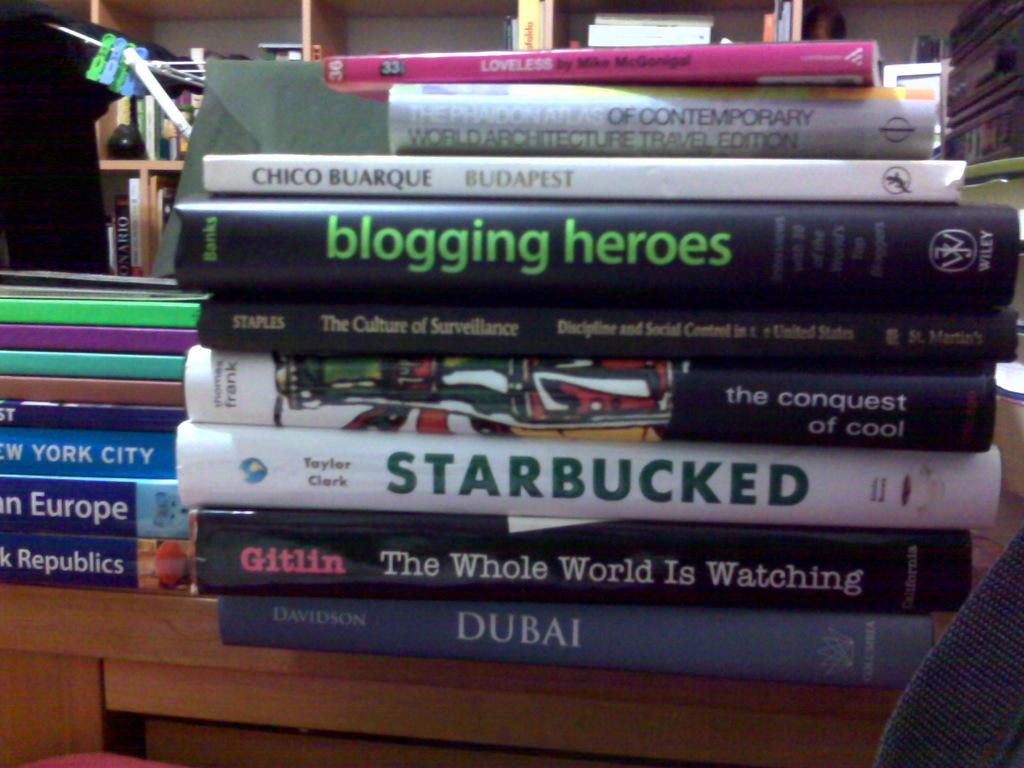Provide a one-sentence caption for the provided image. White Starbucked book by Taylor Clark in the middle of other books. 